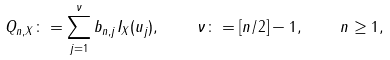<formula> <loc_0><loc_0><loc_500><loc_500>Q _ { n , X } \colon = \sum _ { j = 1 } ^ { \nu } b _ { n , j } I _ { X } ( u _ { j } ) , \quad \nu \colon = [ n / 2 ] - 1 , \quad n \geq 1 ,</formula> 